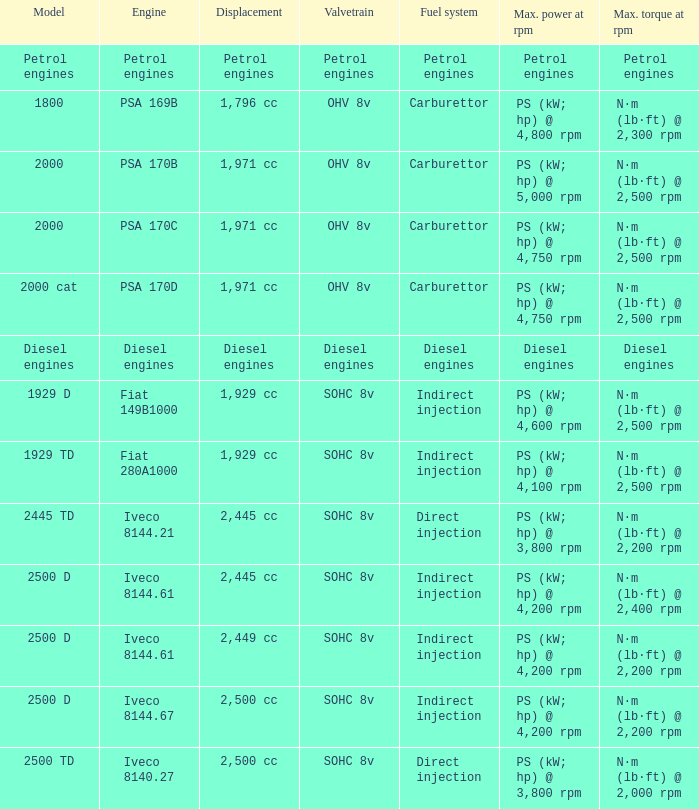What is the peak torque for a 2,445 cc displacement and an iveco 814 N·m (lb·ft) @ 2,400 rpm. 